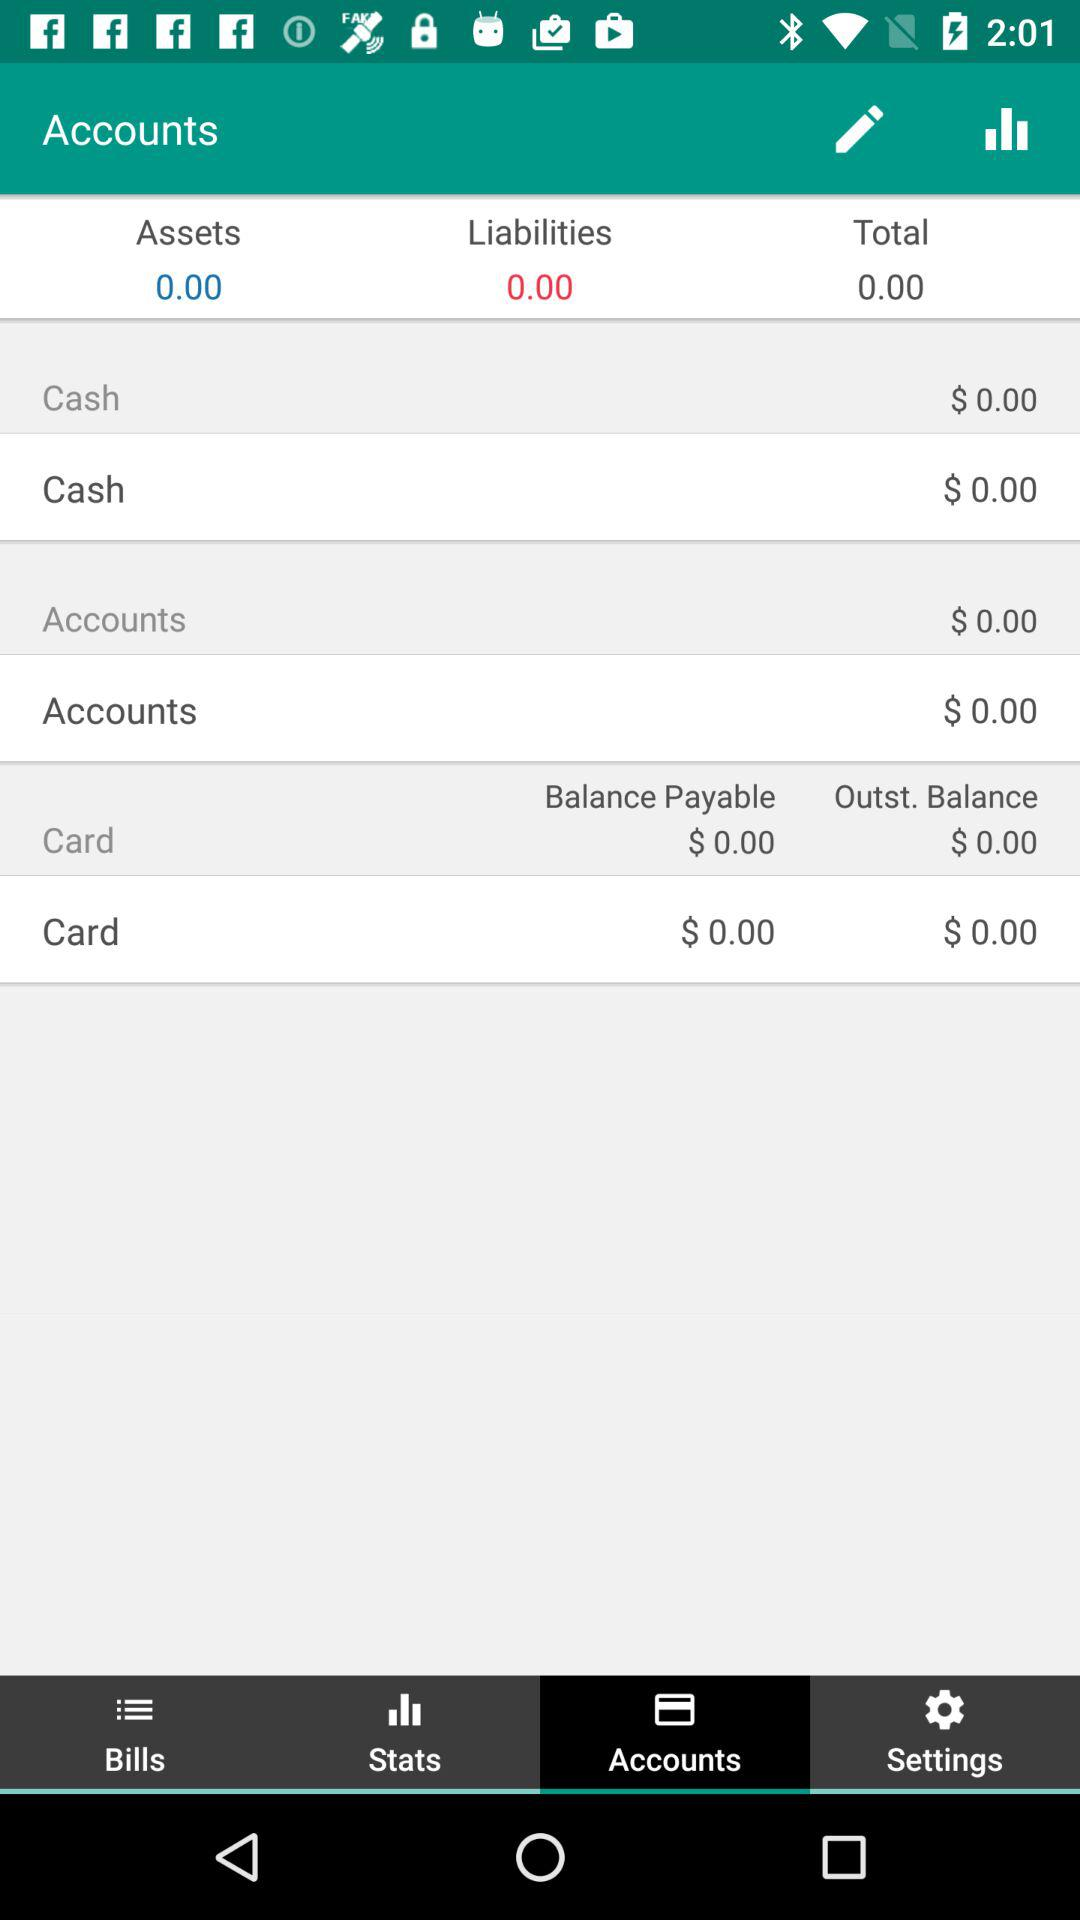What is the total amount of assets? The total amount of assets is 0. 